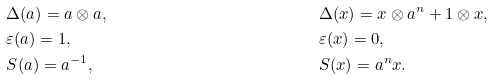<formula> <loc_0><loc_0><loc_500><loc_500>& \Delta ( a ) = a \otimes a , & & \Delta ( x ) = x \otimes a ^ { n } + 1 \otimes x , \\ & \varepsilon ( a ) = 1 , & & \varepsilon ( x ) = 0 , \\ & S ( a ) = a ^ { - 1 } , & & S ( x ) = a ^ { n } x .</formula> 